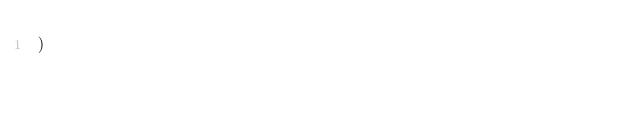Convert code to text. <code><loc_0><loc_0><loc_500><loc_500><_SQL_>)</code> 